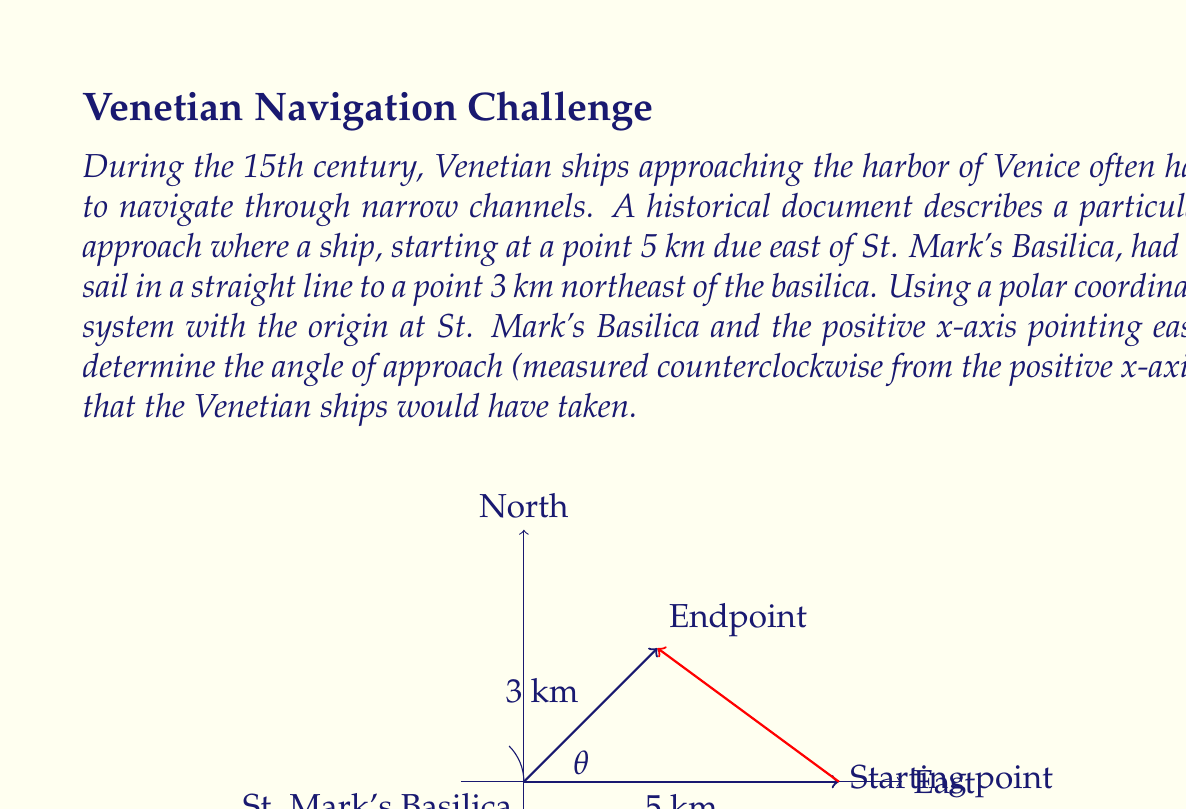Could you help me with this problem? To solve this problem, we need to use polar coordinates and basic trigonometry. Let's approach this step-by-step:

1) First, let's identify the coordinates of the two points:
   - Starting point: $(5, 0)$ in Cartesian coordinates, or $(5, 0°)$ in polar coordinates
   - Endpoint: $(3\cos 45°, 3\sin 45°)$ in Cartesian coordinates, or $(3, 45°)$ in polar coordinates

2) To find the angle of approach, we need to calculate the angle between the line connecting these two points and the positive x-axis.

3) We can use the arctangent function to find this angle. The formula is:

   $$\theta = \arctan(\frac{y_2 - y_1}{x_2 - x_1})$$

   Where $(x_1, y_1)$ is the starting point and $(x_2, y_2)$ is the endpoint.

4) Let's calculate the coordinates of the endpoint in Cartesian form:
   $x_2 = 3\cos 45° = 3 \cdot \frac{\sqrt{2}}{2} \approx 2.12$
   $y_2 = 3\sin 45° = 3 \cdot \frac{\sqrt{2}}{2} \approx 2.12$

5) Now we can plug these values into our formula:

   $$\theta = \arctan(\frac{2.12 - 0}{2.12 - 5}) = \arctan(\frac{2.12}{-2.88})$$

6) Calculating this:

   $$\theta \approx -0.6351 \text{ radians}$$

7) Convert to degrees:

   $$\theta \approx -36.40°$$

8) However, this is the angle from the positive x-axis to the line in the clockwise direction. We need the counterclockwise angle, which is:

   $$360° - 36.40° = 323.60°$$

Therefore, the angle of approach for the Venetian ships would have been approximately 323.60° measured counterclockwise from the positive x-axis.
Answer: $323.60°$ 